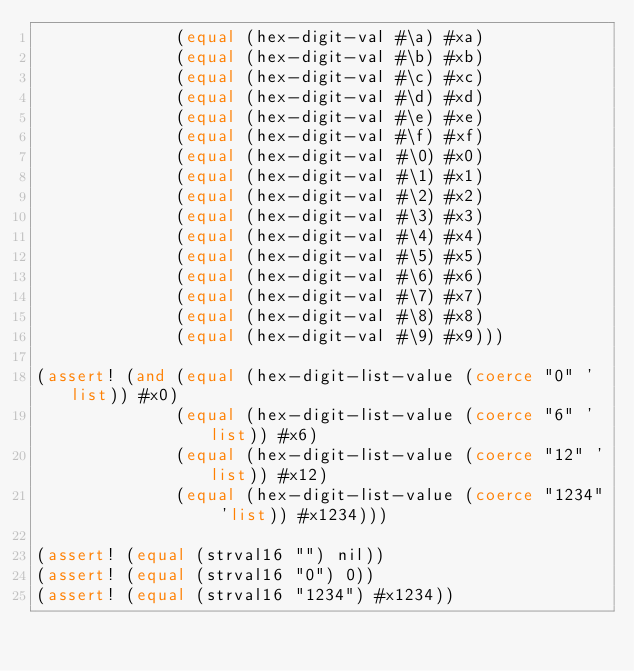Convert code to text. <code><loc_0><loc_0><loc_500><loc_500><_Lisp_>              (equal (hex-digit-val #\a) #xa)
              (equal (hex-digit-val #\b) #xb)
              (equal (hex-digit-val #\c) #xc)
              (equal (hex-digit-val #\d) #xd)
              (equal (hex-digit-val #\e) #xe)
              (equal (hex-digit-val #\f) #xf)
              (equal (hex-digit-val #\0) #x0)
              (equal (hex-digit-val #\1) #x1)
              (equal (hex-digit-val #\2) #x2)
              (equal (hex-digit-val #\3) #x3)
              (equal (hex-digit-val #\4) #x4)
              (equal (hex-digit-val #\5) #x5)
              (equal (hex-digit-val #\6) #x6)
              (equal (hex-digit-val #\7) #x7)
              (equal (hex-digit-val #\8) #x8)
              (equal (hex-digit-val #\9) #x9)))

(assert! (and (equal (hex-digit-list-value (coerce "0" 'list)) #x0)
              (equal (hex-digit-list-value (coerce "6" 'list)) #x6)
              (equal (hex-digit-list-value (coerce "12" 'list)) #x12)
              (equal (hex-digit-list-value (coerce "1234" 'list)) #x1234)))

(assert! (equal (strval16 "") nil))
(assert! (equal (strval16 "0") 0))
(assert! (equal (strval16 "1234") #x1234))
</code> 